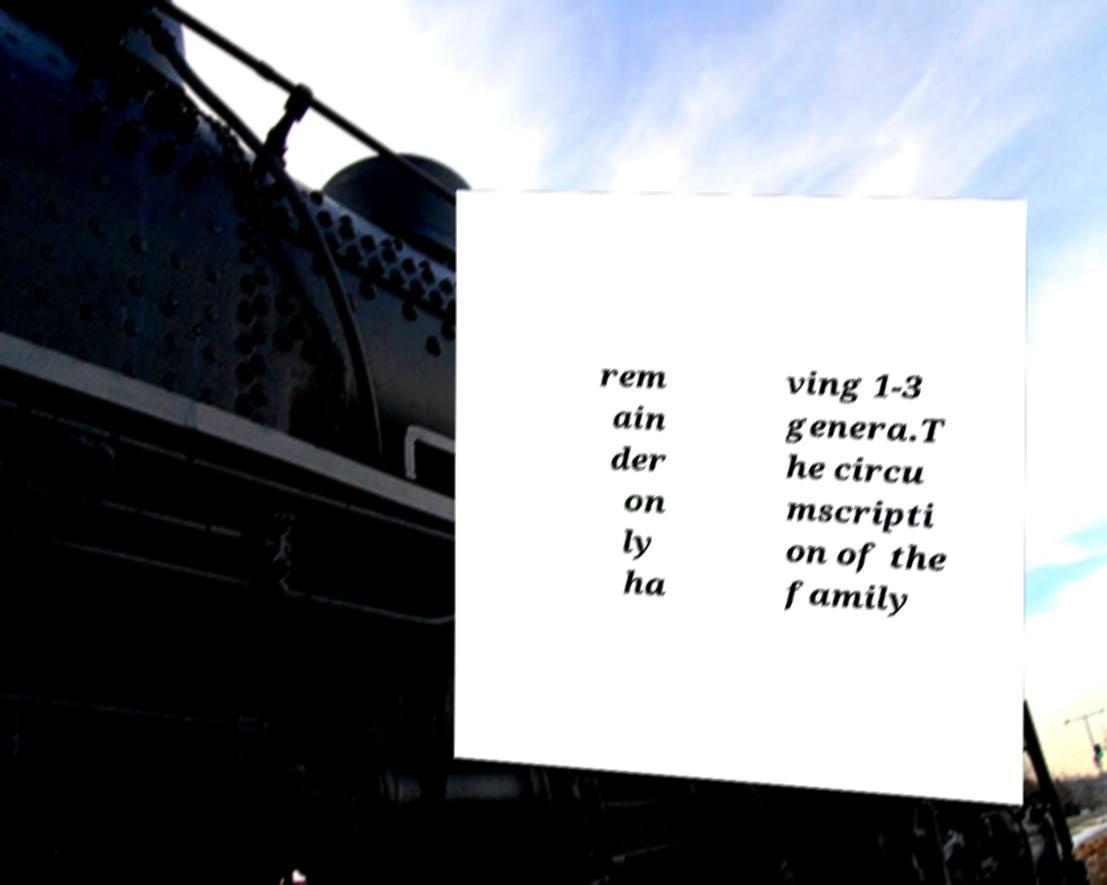What messages or text are displayed in this image? I need them in a readable, typed format. rem ain der on ly ha ving 1-3 genera.T he circu mscripti on of the family 